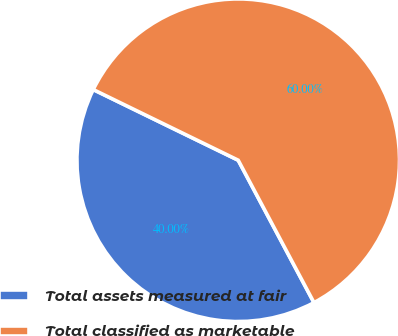<chart> <loc_0><loc_0><loc_500><loc_500><pie_chart><fcel>Total assets measured at fair<fcel>Total classified as marketable<nl><fcel>40.0%<fcel>60.0%<nl></chart> 